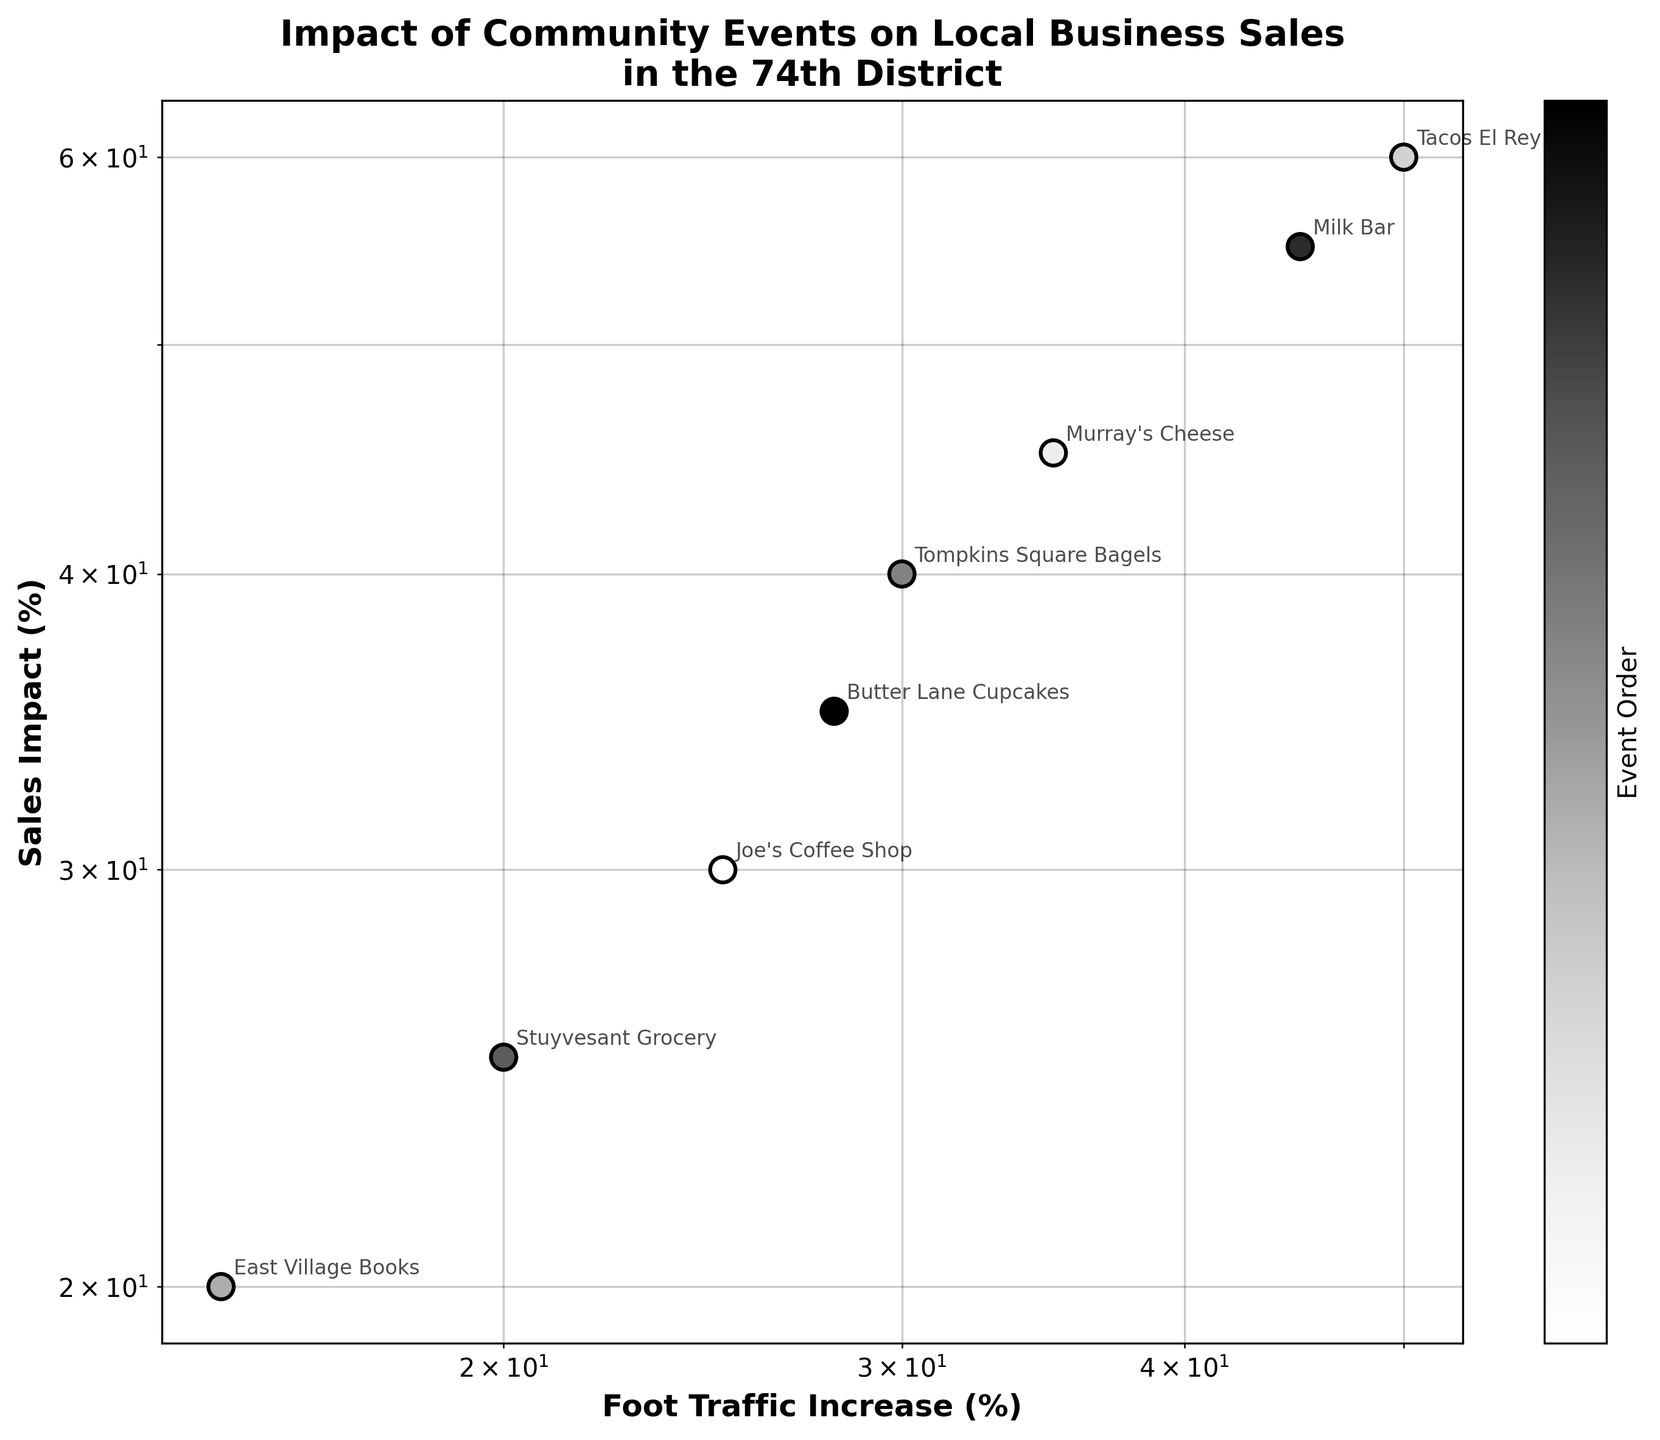What's the title of the plot? The title of the plot is written at the top of the figure.
Answer: Impact of Community Events on Local Business Sales in the 74th District What does the x-axis represent? The x-axis represents the increase in foot traffic percentage, which can be seen from the label at the bottom of the axis.
Answer: Foot Traffic Increase (%) Which event had the highest sales impact? By observing the highest point on the y-axis, we can see that Tacos El Rey had the highest sales impact due to the Food Festival.
Answer: Food Festival How many data points are plotted in the scatter plot? Each data point represents a local business, and by counting all such data points in the plot, we determine there are 8.
Answer: 8 What is the color scheme used in the scatter plot? The scatter plot utilizes a grayscale color scheme, which is evident from the varying shades of gray used for different data points.
Answer: Grayscale Which local business had the lowest foot traffic increase and what event was it associated with? By identifying the leftmost data point on the x-axis, we see that East Village Books had the lowest foot traffic increase associated with the Holiday Bazaar.
Answer: East Village Books, Holiday Bazaar What is the general relationship between foot traffic increase and sales impact in this plot? By observing the trend of data points, we can see that there is a positive relationship: as foot traffic increases, sales impact also tends to increase.
Answer: Positive relationship Calculate the average sales impact for all local businesses. Adding all the sales impact percentages (30 + 45 + 60 + 20 + 40 + 25 + 55 + 35) and then dividing by the number of data points (8) gives (30 + 45 + 60 + 20 + 40 + 25 + 55 + 35) / 8 = 38.75.
Answer: 38.75% Compare foot traffic increases for Milk Bar and Joe's Coffee Shop. Which one is higher and by how much? Milk Bar has a foot traffic increase of 45% and Joe's Coffee Shop has 25%. Subtracting 25 from 45 gives 20%.
Answer: Milk Bar, 20% What does the use of a log scale indicate about the relationship being analyzed? The use of a log scale indicates that the data spans several orders of magnitude, and this scale helps to more clearly show proportional relationships in a compressed form.
Answer: Log scale normalizes wide-ranging data 